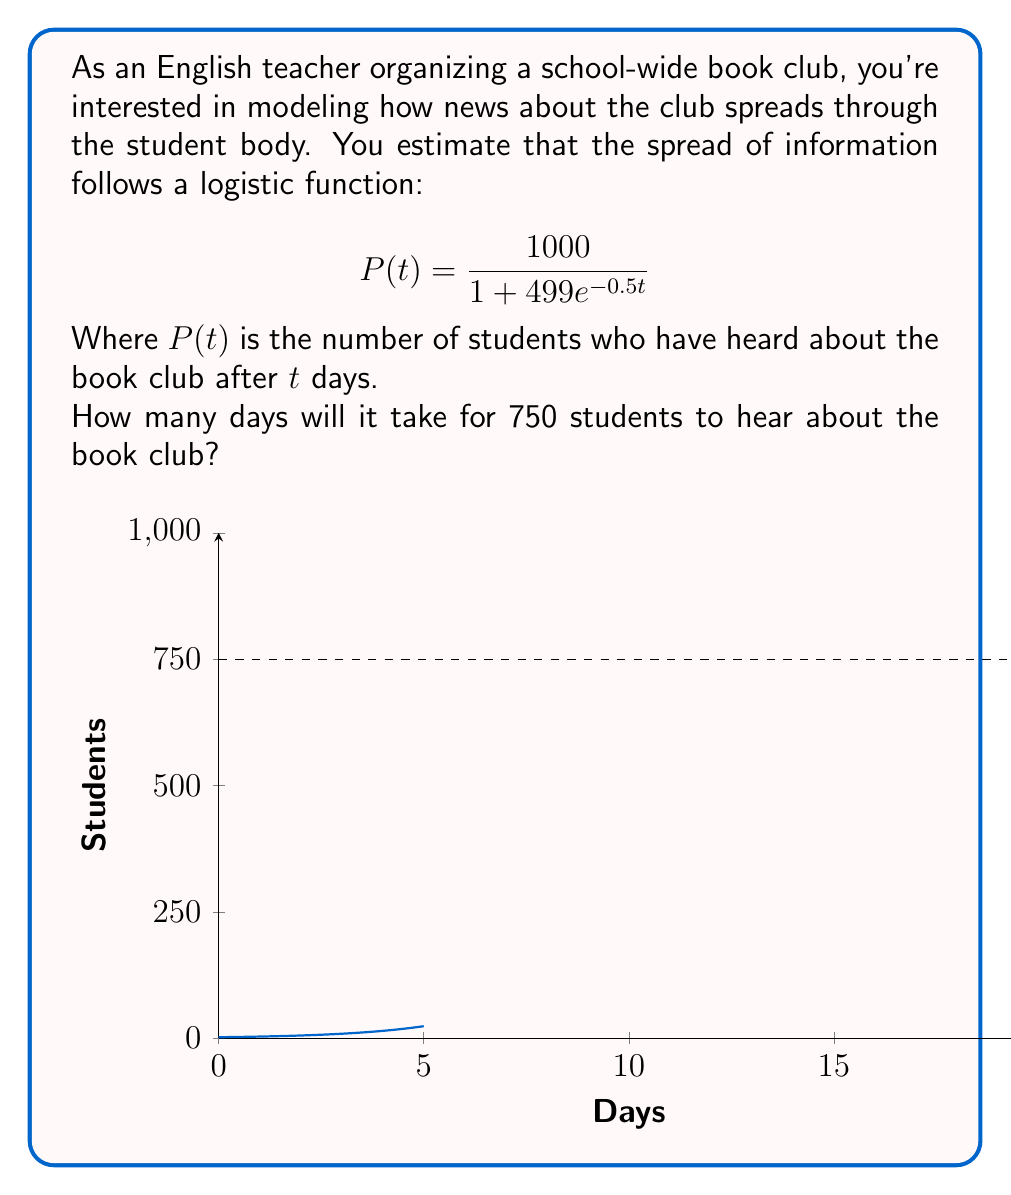Could you help me with this problem? Let's approach this step-by-step:

1) We want to find $t$ when $P(t) = 750$. So, we set up the equation:

   $$750 = \frac{1000}{1 + 499e^{-0.5t}}$$

2) Multiply both sides by the denominator:

   $$750(1 + 499e^{-0.5t}) = 1000$$

3) Distribute on the left side:

   $$750 + 374250e^{-0.5t} = 1000$$

4) Subtract 750 from both sides:

   $$374250e^{-0.5t} = 250$$

5) Divide both sides by 374250:

   $$e^{-0.5t} = \frac{1}{1497}$$

6) Take the natural log of both sides:

   $$-0.5t = \ln(\frac{1}{1497})$$

7) Multiply both sides by -2:

   $$t = -2\ln(\frac{1}{1497})$$

8) Simplify:

   $$t = 2\ln(1497) \approx 14.62$$

Therefore, it will take approximately 14.62 days for 750 students to hear about the book club.
Answer: $2\ln(1497) \approx 14.62$ days 